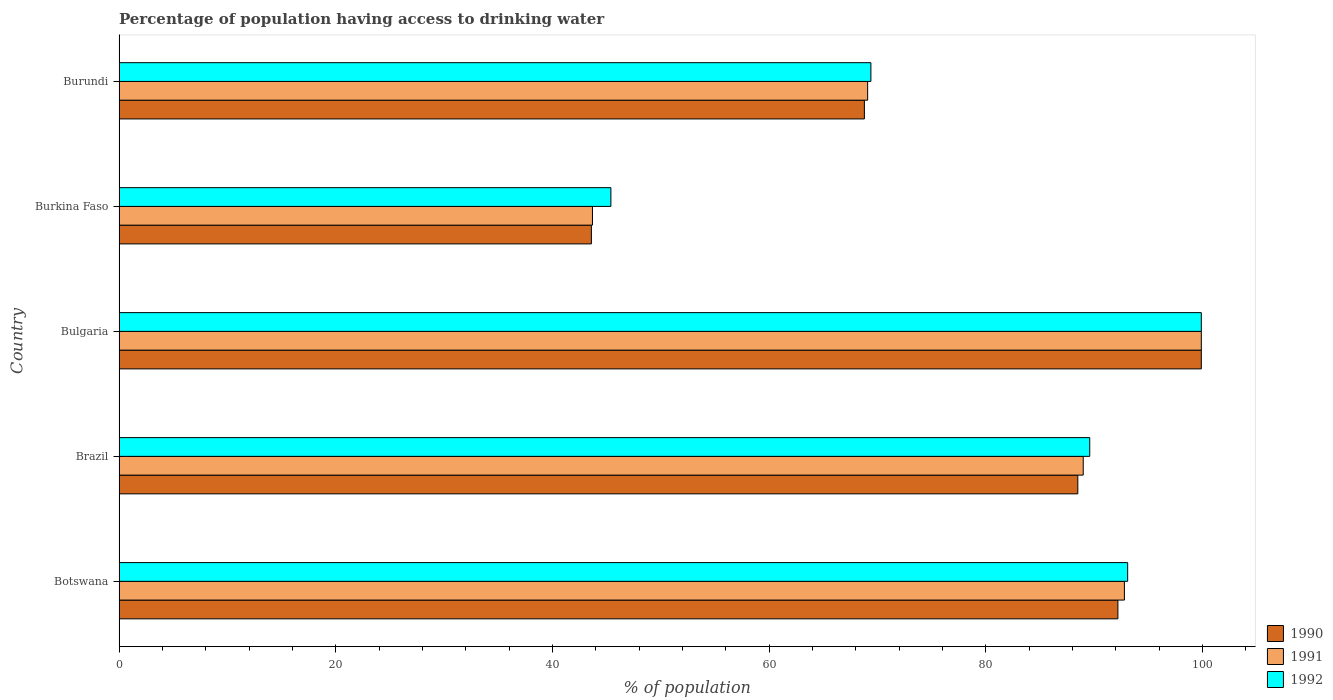How many groups of bars are there?
Your answer should be very brief. 5. Are the number of bars per tick equal to the number of legend labels?
Your answer should be very brief. Yes. Are the number of bars on each tick of the Y-axis equal?
Your response must be concise. Yes. How many bars are there on the 2nd tick from the top?
Provide a short and direct response. 3. How many bars are there on the 5th tick from the bottom?
Make the answer very short. 3. What is the label of the 4th group of bars from the top?
Give a very brief answer. Brazil. In how many cases, is the number of bars for a given country not equal to the number of legend labels?
Provide a succinct answer. 0. What is the percentage of population having access to drinking water in 1990 in Burundi?
Give a very brief answer. 68.8. Across all countries, what is the maximum percentage of population having access to drinking water in 1991?
Your answer should be very brief. 99.9. Across all countries, what is the minimum percentage of population having access to drinking water in 1991?
Ensure brevity in your answer.  43.7. In which country was the percentage of population having access to drinking water in 1992 maximum?
Your answer should be compact. Bulgaria. In which country was the percentage of population having access to drinking water in 1990 minimum?
Provide a short and direct response. Burkina Faso. What is the total percentage of population having access to drinking water in 1992 in the graph?
Provide a short and direct response. 397.4. What is the difference between the percentage of population having access to drinking water in 1991 in Burkina Faso and the percentage of population having access to drinking water in 1990 in Burundi?
Your answer should be compact. -25.1. What is the average percentage of population having access to drinking water in 1990 per country?
Provide a short and direct response. 78.6. What is the difference between the percentage of population having access to drinking water in 1990 and percentage of population having access to drinking water in 1992 in Burkina Faso?
Your answer should be compact. -1.8. What is the ratio of the percentage of population having access to drinking water in 1990 in Botswana to that in Burundi?
Your response must be concise. 1.34. Is the percentage of population having access to drinking water in 1991 in Botswana less than that in Bulgaria?
Keep it short and to the point. Yes. Is the difference between the percentage of population having access to drinking water in 1990 in Botswana and Burkina Faso greater than the difference between the percentage of population having access to drinking water in 1992 in Botswana and Burkina Faso?
Ensure brevity in your answer.  Yes. What is the difference between the highest and the second highest percentage of population having access to drinking water in 1990?
Ensure brevity in your answer.  7.7. What is the difference between the highest and the lowest percentage of population having access to drinking water in 1990?
Ensure brevity in your answer.  56.3. In how many countries, is the percentage of population having access to drinking water in 1992 greater than the average percentage of population having access to drinking water in 1992 taken over all countries?
Give a very brief answer. 3. What does the 1st bar from the top in Burundi represents?
Make the answer very short. 1992. What does the 3rd bar from the bottom in Brazil represents?
Your answer should be compact. 1992. How many bars are there?
Make the answer very short. 15. How many countries are there in the graph?
Offer a terse response. 5. How many legend labels are there?
Provide a succinct answer. 3. How are the legend labels stacked?
Your answer should be very brief. Vertical. What is the title of the graph?
Provide a succinct answer. Percentage of population having access to drinking water. Does "1980" appear as one of the legend labels in the graph?
Your answer should be very brief. No. What is the label or title of the X-axis?
Offer a very short reply. % of population. What is the label or title of the Y-axis?
Make the answer very short. Country. What is the % of population of 1990 in Botswana?
Give a very brief answer. 92.2. What is the % of population in 1991 in Botswana?
Give a very brief answer. 92.8. What is the % of population of 1992 in Botswana?
Provide a short and direct response. 93.1. What is the % of population of 1990 in Brazil?
Your answer should be compact. 88.5. What is the % of population in 1991 in Brazil?
Give a very brief answer. 89. What is the % of population of 1992 in Brazil?
Your answer should be very brief. 89.6. What is the % of population in 1990 in Bulgaria?
Your answer should be very brief. 99.9. What is the % of population of 1991 in Bulgaria?
Your answer should be compact. 99.9. What is the % of population of 1992 in Bulgaria?
Your answer should be compact. 99.9. What is the % of population of 1990 in Burkina Faso?
Provide a succinct answer. 43.6. What is the % of population of 1991 in Burkina Faso?
Your answer should be very brief. 43.7. What is the % of population in 1992 in Burkina Faso?
Offer a terse response. 45.4. What is the % of population of 1990 in Burundi?
Your response must be concise. 68.8. What is the % of population in 1991 in Burundi?
Provide a succinct answer. 69.1. What is the % of population of 1992 in Burundi?
Provide a succinct answer. 69.4. Across all countries, what is the maximum % of population of 1990?
Ensure brevity in your answer.  99.9. Across all countries, what is the maximum % of population of 1991?
Offer a terse response. 99.9. Across all countries, what is the maximum % of population of 1992?
Your answer should be very brief. 99.9. Across all countries, what is the minimum % of population in 1990?
Provide a succinct answer. 43.6. Across all countries, what is the minimum % of population of 1991?
Provide a short and direct response. 43.7. Across all countries, what is the minimum % of population of 1992?
Your response must be concise. 45.4. What is the total % of population in 1990 in the graph?
Your response must be concise. 393. What is the total % of population of 1991 in the graph?
Provide a succinct answer. 394.5. What is the total % of population in 1992 in the graph?
Provide a succinct answer. 397.4. What is the difference between the % of population of 1991 in Botswana and that in Brazil?
Provide a short and direct response. 3.8. What is the difference between the % of population in 1990 in Botswana and that in Bulgaria?
Give a very brief answer. -7.7. What is the difference between the % of population of 1991 in Botswana and that in Bulgaria?
Ensure brevity in your answer.  -7.1. What is the difference between the % of population of 1990 in Botswana and that in Burkina Faso?
Your response must be concise. 48.6. What is the difference between the % of population of 1991 in Botswana and that in Burkina Faso?
Provide a succinct answer. 49.1. What is the difference between the % of population in 1992 in Botswana and that in Burkina Faso?
Provide a succinct answer. 47.7. What is the difference between the % of population of 1990 in Botswana and that in Burundi?
Give a very brief answer. 23.4. What is the difference between the % of population in 1991 in Botswana and that in Burundi?
Your answer should be compact. 23.7. What is the difference between the % of population in 1992 in Botswana and that in Burundi?
Your response must be concise. 23.7. What is the difference between the % of population of 1992 in Brazil and that in Bulgaria?
Give a very brief answer. -10.3. What is the difference between the % of population of 1990 in Brazil and that in Burkina Faso?
Provide a short and direct response. 44.9. What is the difference between the % of population of 1991 in Brazil and that in Burkina Faso?
Provide a short and direct response. 45.3. What is the difference between the % of population in 1992 in Brazil and that in Burkina Faso?
Your response must be concise. 44.2. What is the difference between the % of population of 1992 in Brazil and that in Burundi?
Your response must be concise. 20.2. What is the difference between the % of population of 1990 in Bulgaria and that in Burkina Faso?
Your response must be concise. 56.3. What is the difference between the % of population of 1991 in Bulgaria and that in Burkina Faso?
Provide a short and direct response. 56.2. What is the difference between the % of population in 1992 in Bulgaria and that in Burkina Faso?
Give a very brief answer. 54.5. What is the difference between the % of population in 1990 in Bulgaria and that in Burundi?
Your answer should be compact. 31.1. What is the difference between the % of population of 1991 in Bulgaria and that in Burundi?
Keep it short and to the point. 30.8. What is the difference between the % of population of 1992 in Bulgaria and that in Burundi?
Give a very brief answer. 30.5. What is the difference between the % of population in 1990 in Burkina Faso and that in Burundi?
Your response must be concise. -25.2. What is the difference between the % of population in 1991 in Burkina Faso and that in Burundi?
Ensure brevity in your answer.  -25.4. What is the difference between the % of population of 1990 in Botswana and the % of population of 1991 in Brazil?
Your response must be concise. 3.2. What is the difference between the % of population in 1990 in Botswana and the % of population in 1992 in Brazil?
Keep it short and to the point. 2.6. What is the difference between the % of population in 1990 in Botswana and the % of population in 1991 in Bulgaria?
Your answer should be very brief. -7.7. What is the difference between the % of population of 1990 in Botswana and the % of population of 1992 in Bulgaria?
Keep it short and to the point. -7.7. What is the difference between the % of population of 1990 in Botswana and the % of population of 1991 in Burkina Faso?
Provide a succinct answer. 48.5. What is the difference between the % of population in 1990 in Botswana and the % of population in 1992 in Burkina Faso?
Provide a succinct answer. 46.8. What is the difference between the % of population of 1991 in Botswana and the % of population of 1992 in Burkina Faso?
Provide a short and direct response. 47.4. What is the difference between the % of population in 1990 in Botswana and the % of population in 1991 in Burundi?
Offer a very short reply. 23.1. What is the difference between the % of population in 1990 in Botswana and the % of population in 1992 in Burundi?
Your answer should be very brief. 22.8. What is the difference between the % of population in 1991 in Botswana and the % of population in 1992 in Burundi?
Your answer should be very brief. 23.4. What is the difference between the % of population in 1990 in Brazil and the % of population in 1991 in Bulgaria?
Keep it short and to the point. -11.4. What is the difference between the % of population in 1990 in Brazil and the % of population in 1991 in Burkina Faso?
Your answer should be very brief. 44.8. What is the difference between the % of population in 1990 in Brazil and the % of population in 1992 in Burkina Faso?
Offer a very short reply. 43.1. What is the difference between the % of population of 1991 in Brazil and the % of population of 1992 in Burkina Faso?
Provide a short and direct response. 43.6. What is the difference between the % of population in 1990 in Brazil and the % of population in 1991 in Burundi?
Offer a terse response. 19.4. What is the difference between the % of population in 1990 in Brazil and the % of population in 1992 in Burundi?
Your response must be concise. 19.1. What is the difference between the % of population of 1991 in Brazil and the % of population of 1992 in Burundi?
Keep it short and to the point. 19.6. What is the difference between the % of population of 1990 in Bulgaria and the % of population of 1991 in Burkina Faso?
Your answer should be very brief. 56.2. What is the difference between the % of population in 1990 in Bulgaria and the % of population in 1992 in Burkina Faso?
Your answer should be very brief. 54.5. What is the difference between the % of population of 1991 in Bulgaria and the % of population of 1992 in Burkina Faso?
Make the answer very short. 54.5. What is the difference between the % of population of 1990 in Bulgaria and the % of population of 1991 in Burundi?
Your answer should be very brief. 30.8. What is the difference between the % of population in 1990 in Bulgaria and the % of population in 1992 in Burundi?
Your response must be concise. 30.5. What is the difference between the % of population in 1991 in Bulgaria and the % of population in 1992 in Burundi?
Your response must be concise. 30.5. What is the difference between the % of population in 1990 in Burkina Faso and the % of population in 1991 in Burundi?
Your response must be concise. -25.5. What is the difference between the % of population in 1990 in Burkina Faso and the % of population in 1992 in Burundi?
Ensure brevity in your answer.  -25.8. What is the difference between the % of population of 1991 in Burkina Faso and the % of population of 1992 in Burundi?
Ensure brevity in your answer.  -25.7. What is the average % of population of 1990 per country?
Offer a very short reply. 78.6. What is the average % of population of 1991 per country?
Your answer should be very brief. 78.9. What is the average % of population of 1992 per country?
Keep it short and to the point. 79.48. What is the difference between the % of population of 1990 and % of population of 1991 in Botswana?
Keep it short and to the point. -0.6. What is the difference between the % of population of 1990 and % of population of 1992 in Brazil?
Offer a terse response. -1.1. What is the difference between the % of population in 1991 and % of population in 1992 in Brazil?
Keep it short and to the point. -0.6. What is the difference between the % of population of 1990 and % of population of 1992 in Bulgaria?
Your response must be concise. 0. What is the difference between the % of population in 1991 and % of population in 1992 in Bulgaria?
Make the answer very short. 0. What is the difference between the % of population of 1991 and % of population of 1992 in Burkina Faso?
Ensure brevity in your answer.  -1.7. What is the difference between the % of population in 1990 and % of population in 1992 in Burundi?
Keep it short and to the point. -0.6. What is the ratio of the % of population in 1990 in Botswana to that in Brazil?
Your answer should be compact. 1.04. What is the ratio of the % of population in 1991 in Botswana to that in Brazil?
Offer a terse response. 1.04. What is the ratio of the % of population of 1992 in Botswana to that in Brazil?
Offer a terse response. 1.04. What is the ratio of the % of population in 1990 in Botswana to that in Bulgaria?
Ensure brevity in your answer.  0.92. What is the ratio of the % of population in 1991 in Botswana to that in Bulgaria?
Offer a very short reply. 0.93. What is the ratio of the % of population of 1992 in Botswana to that in Bulgaria?
Keep it short and to the point. 0.93. What is the ratio of the % of population in 1990 in Botswana to that in Burkina Faso?
Your response must be concise. 2.11. What is the ratio of the % of population of 1991 in Botswana to that in Burkina Faso?
Give a very brief answer. 2.12. What is the ratio of the % of population in 1992 in Botswana to that in Burkina Faso?
Provide a succinct answer. 2.05. What is the ratio of the % of population in 1990 in Botswana to that in Burundi?
Offer a terse response. 1.34. What is the ratio of the % of population in 1991 in Botswana to that in Burundi?
Your answer should be very brief. 1.34. What is the ratio of the % of population in 1992 in Botswana to that in Burundi?
Your response must be concise. 1.34. What is the ratio of the % of population of 1990 in Brazil to that in Bulgaria?
Your answer should be compact. 0.89. What is the ratio of the % of population of 1991 in Brazil to that in Bulgaria?
Your response must be concise. 0.89. What is the ratio of the % of population in 1992 in Brazil to that in Bulgaria?
Your answer should be very brief. 0.9. What is the ratio of the % of population in 1990 in Brazil to that in Burkina Faso?
Your answer should be compact. 2.03. What is the ratio of the % of population of 1991 in Brazil to that in Burkina Faso?
Provide a short and direct response. 2.04. What is the ratio of the % of population in 1992 in Brazil to that in Burkina Faso?
Offer a terse response. 1.97. What is the ratio of the % of population of 1990 in Brazil to that in Burundi?
Provide a succinct answer. 1.29. What is the ratio of the % of population of 1991 in Brazil to that in Burundi?
Give a very brief answer. 1.29. What is the ratio of the % of population of 1992 in Brazil to that in Burundi?
Your response must be concise. 1.29. What is the ratio of the % of population in 1990 in Bulgaria to that in Burkina Faso?
Keep it short and to the point. 2.29. What is the ratio of the % of population in 1991 in Bulgaria to that in Burkina Faso?
Provide a succinct answer. 2.29. What is the ratio of the % of population of 1992 in Bulgaria to that in Burkina Faso?
Give a very brief answer. 2.2. What is the ratio of the % of population of 1990 in Bulgaria to that in Burundi?
Provide a short and direct response. 1.45. What is the ratio of the % of population of 1991 in Bulgaria to that in Burundi?
Keep it short and to the point. 1.45. What is the ratio of the % of population of 1992 in Bulgaria to that in Burundi?
Ensure brevity in your answer.  1.44. What is the ratio of the % of population in 1990 in Burkina Faso to that in Burundi?
Give a very brief answer. 0.63. What is the ratio of the % of population of 1991 in Burkina Faso to that in Burundi?
Your answer should be compact. 0.63. What is the ratio of the % of population in 1992 in Burkina Faso to that in Burundi?
Provide a short and direct response. 0.65. What is the difference between the highest and the second highest % of population in 1991?
Make the answer very short. 7.1. What is the difference between the highest and the second highest % of population in 1992?
Provide a succinct answer. 6.8. What is the difference between the highest and the lowest % of population in 1990?
Your answer should be very brief. 56.3. What is the difference between the highest and the lowest % of population of 1991?
Keep it short and to the point. 56.2. What is the difference between the highest and the lowest % of population in 1992?
Your answer should be compact. 54.5. 